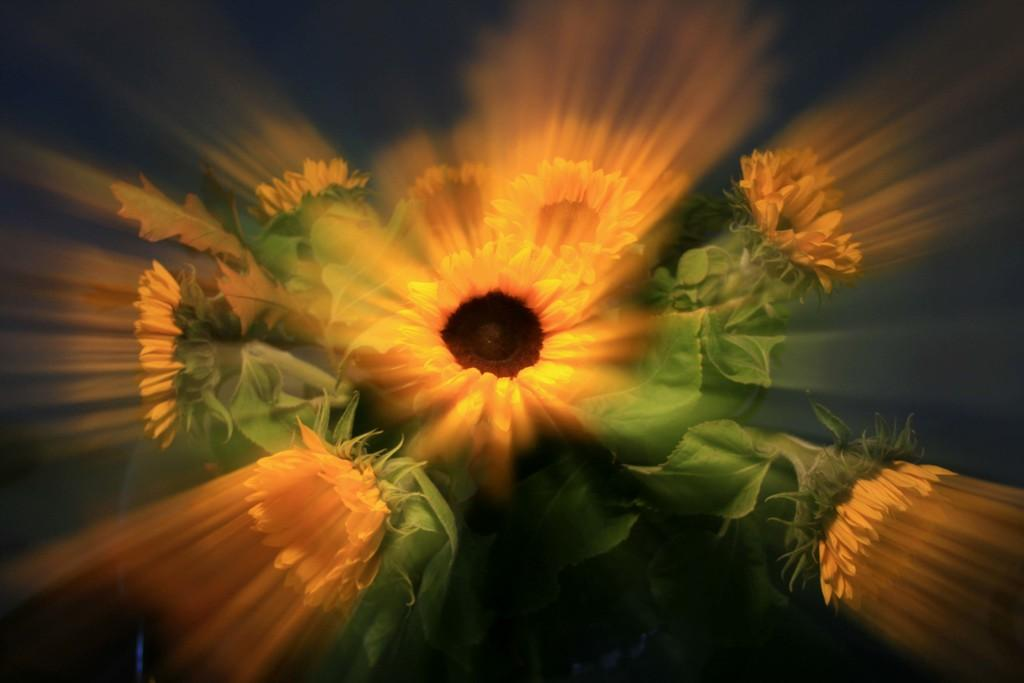What can be observed about the image's appearance? The image appears to be edited. What type of flowers can be seen in the image? There are flowers in yellow color in the image. What other elements are present in the image besides the flowers? There are leaves in the image. How many oranges are hanging from the tree in the image? There is no tree or oranges present in the image; it features flowers and leaves. What type of detail can be seen on the petals of the flowers in the image? The image does not provide enough detail to observe specific features on the petals of the flowers. 